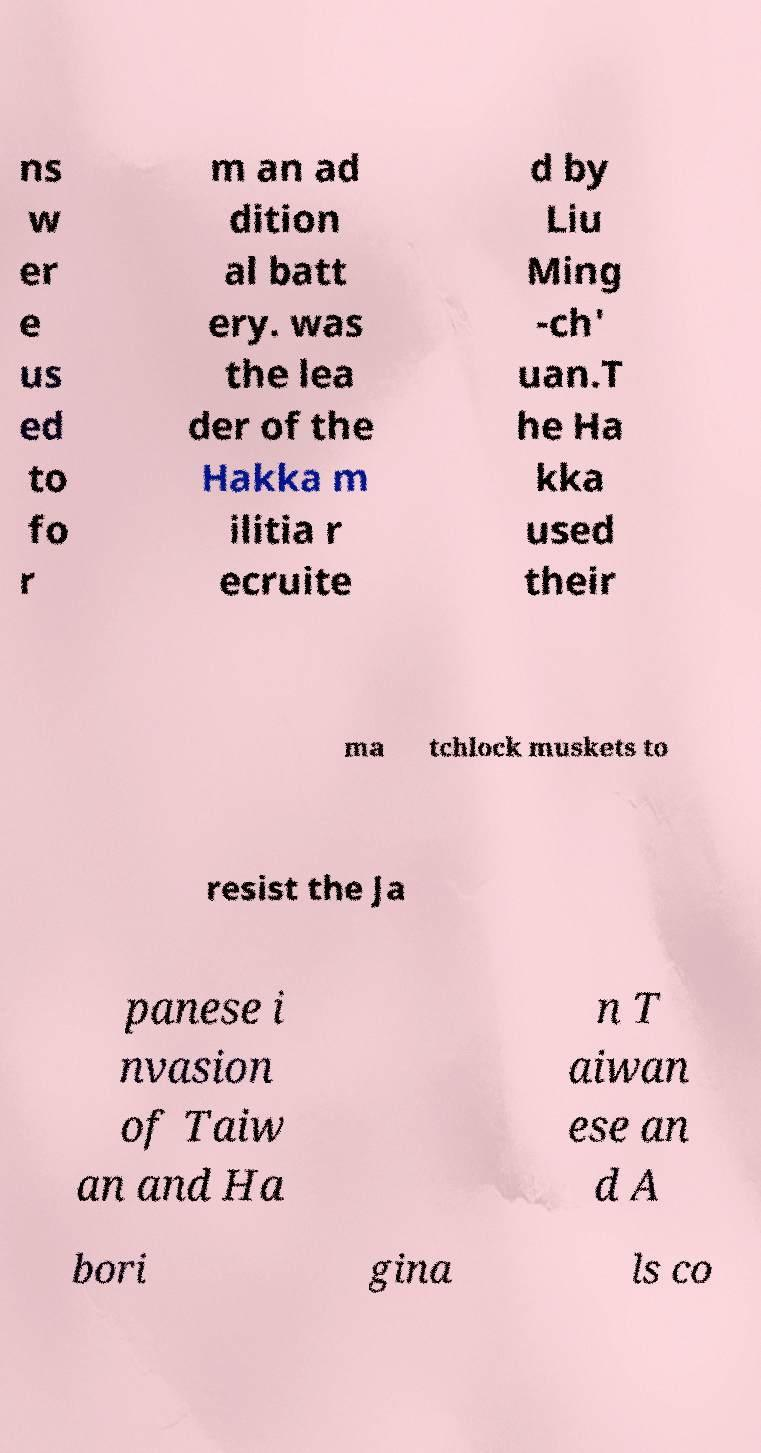I need the written content from this picture converted into text. Can you do that? ns w er e us ed to fo r m an ad dition al batt ery. was the lea der of the Hakka m ilitia r ecruite d by Liu Ming -ch' uan.T he Ha kka used their ma tchlock muskets to resist the Ja panese i nvasion of Taiw an and Ha n T aiwan ese an d A bori gina ls co 